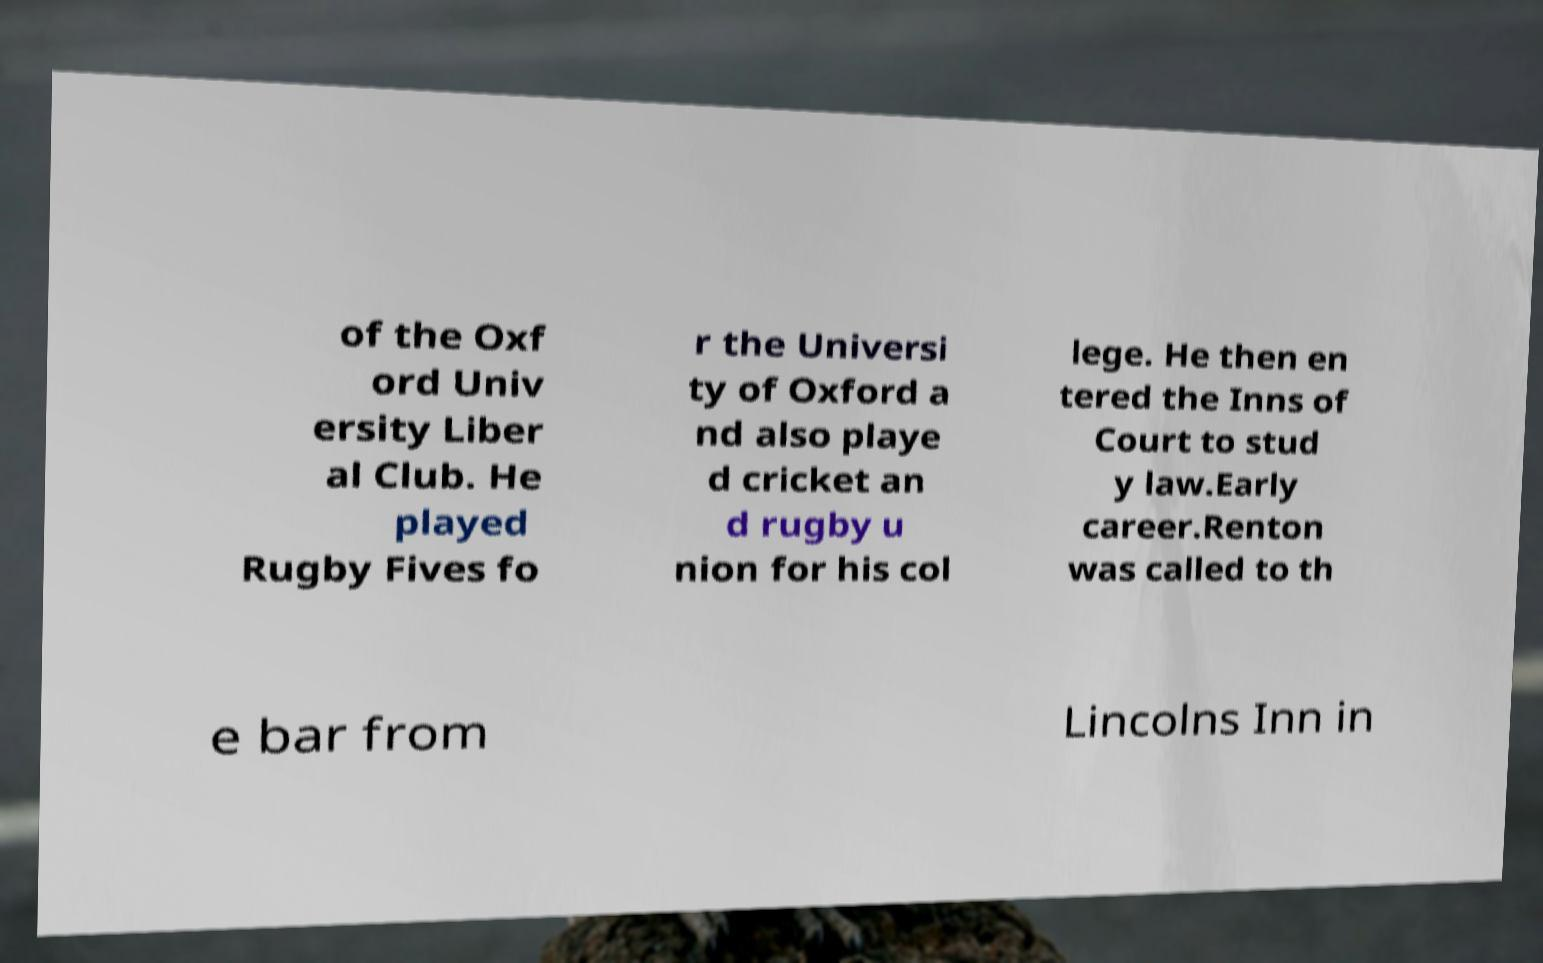I need the written content from this picture converted into text. Can you do that? of the Oxf ord Univ ersity Liber al Club. He played Rugby Fives fo r the Universi ty of Oxford a nd also playe d cricket an d rugby u nion for his col lege. He then en tered the Inns of Court to stud y law.Early career.Renton was called to th e bar from Lincolns Inn in 